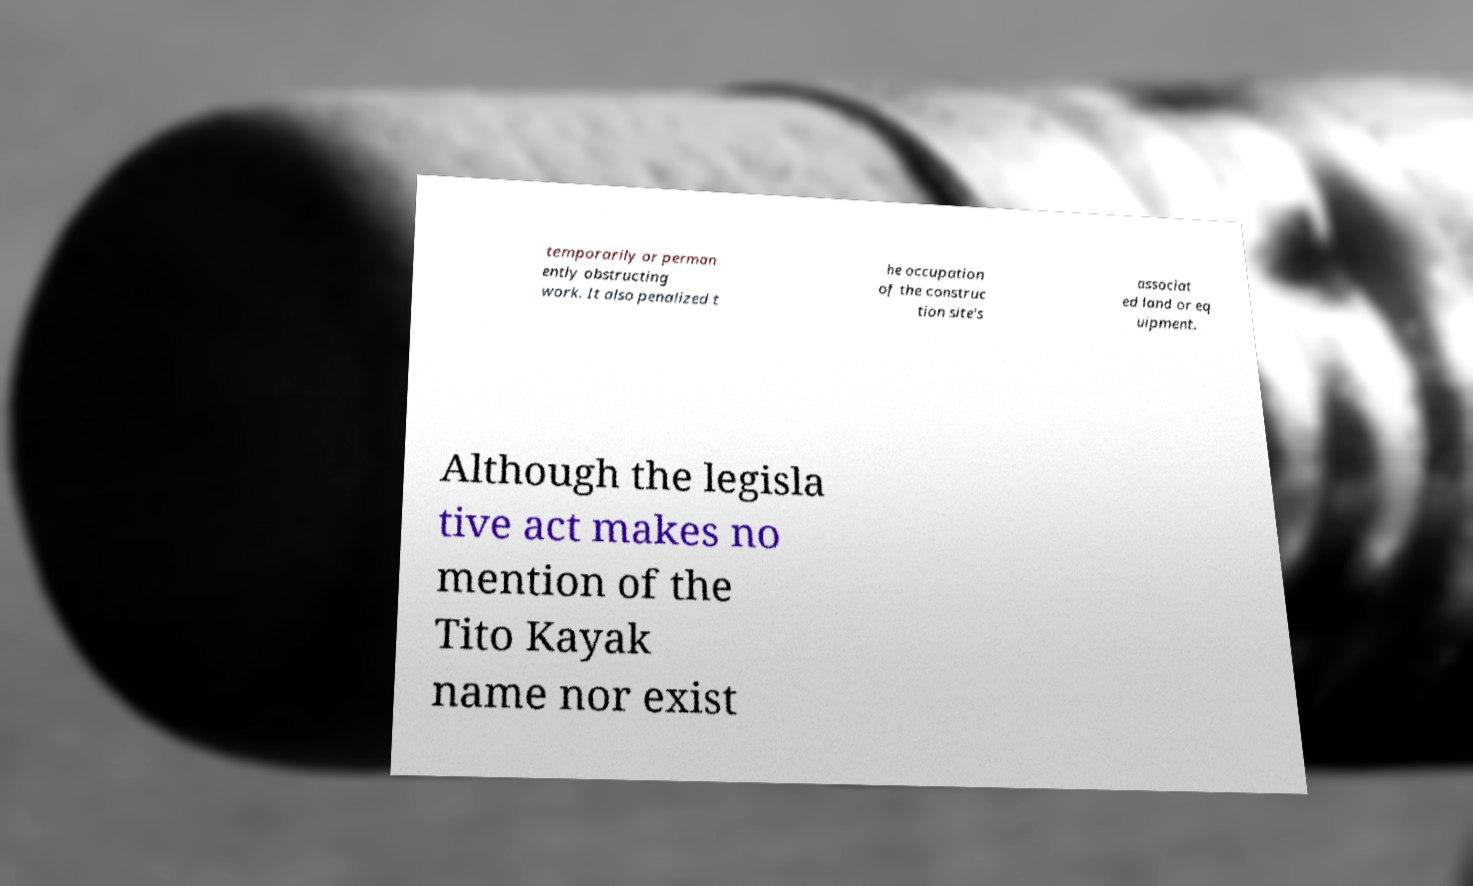Could you extract and type out the text from this image? temporarily or perman ently obstructing work. It also penalized t he occupation of the construc tion site's associat ed land or eq uipment. Although the legisla tive act makes no mention of the Tito Kayak name nor exist 